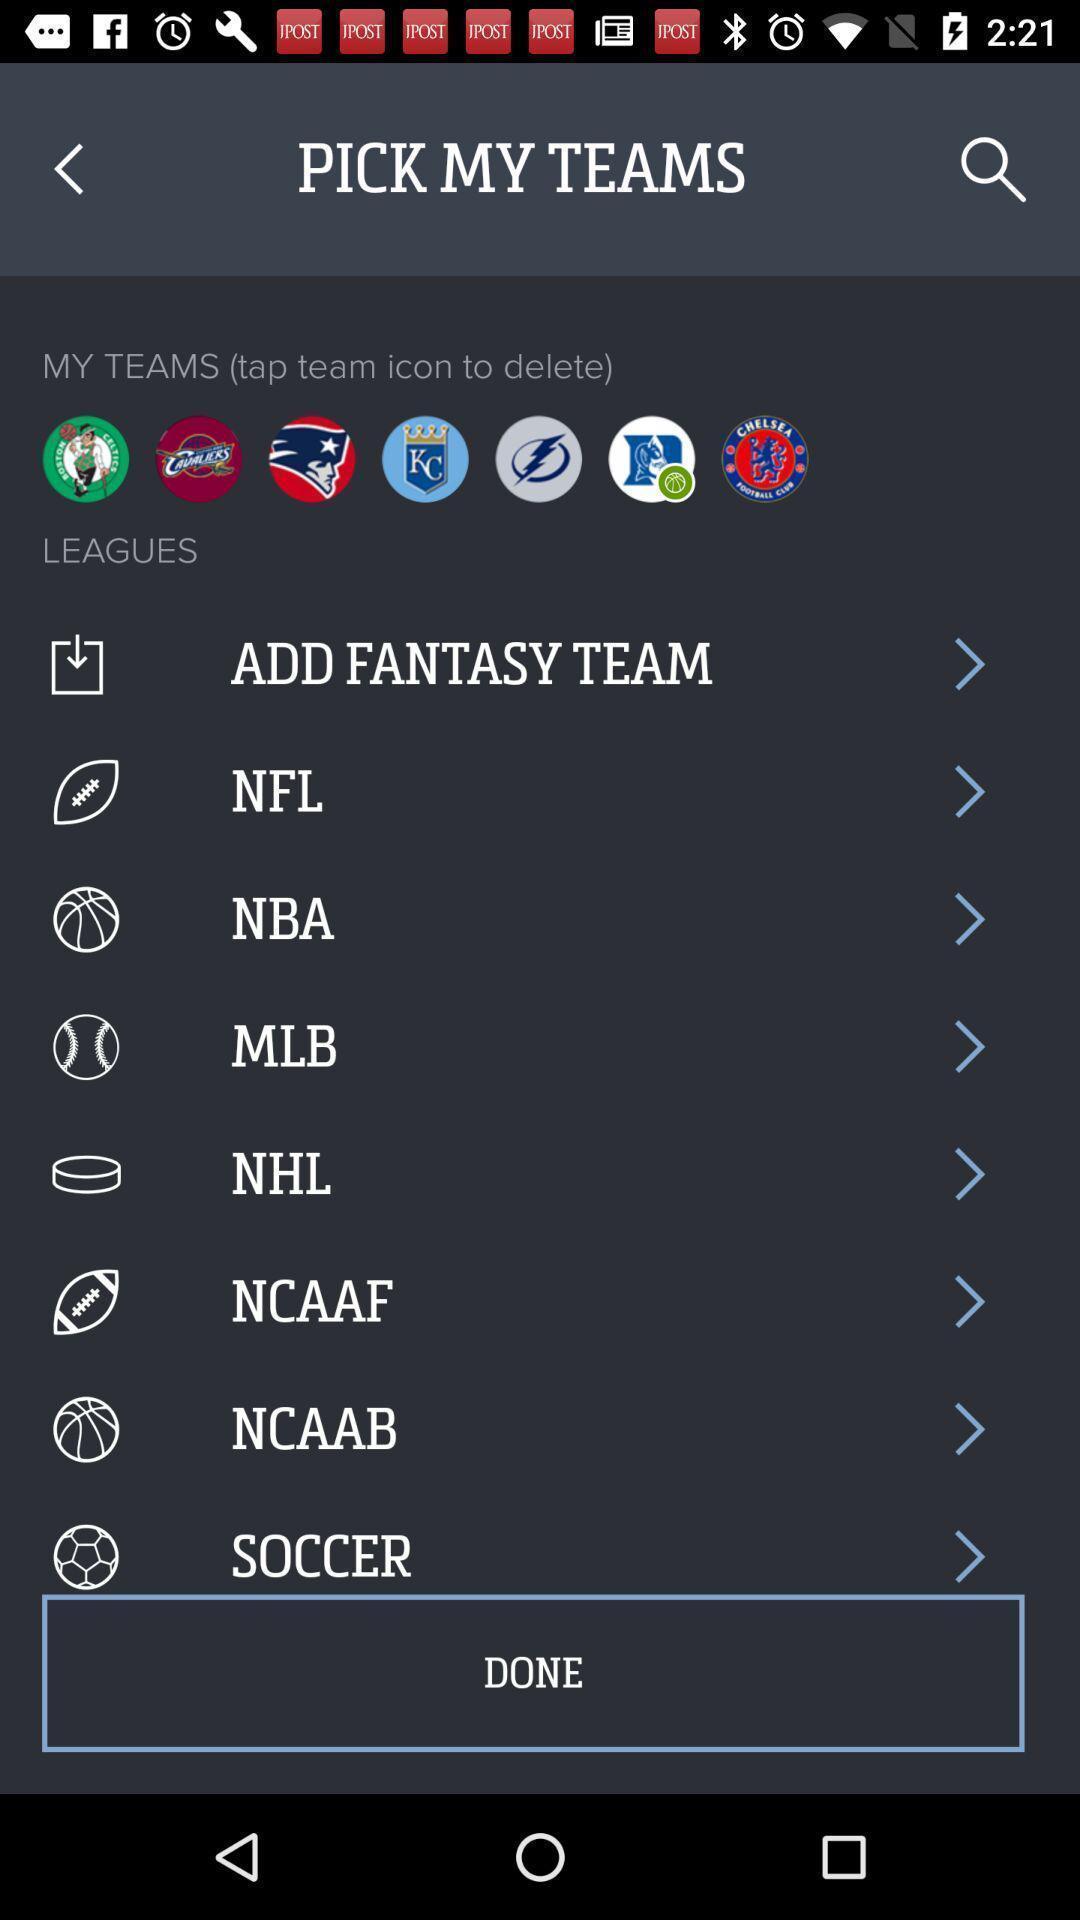Summarize the main components in this picture. Page for selecting a team of a sports app. 